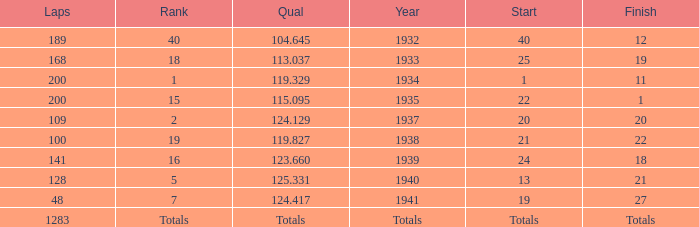What year did he start at 13? 1940.0. 